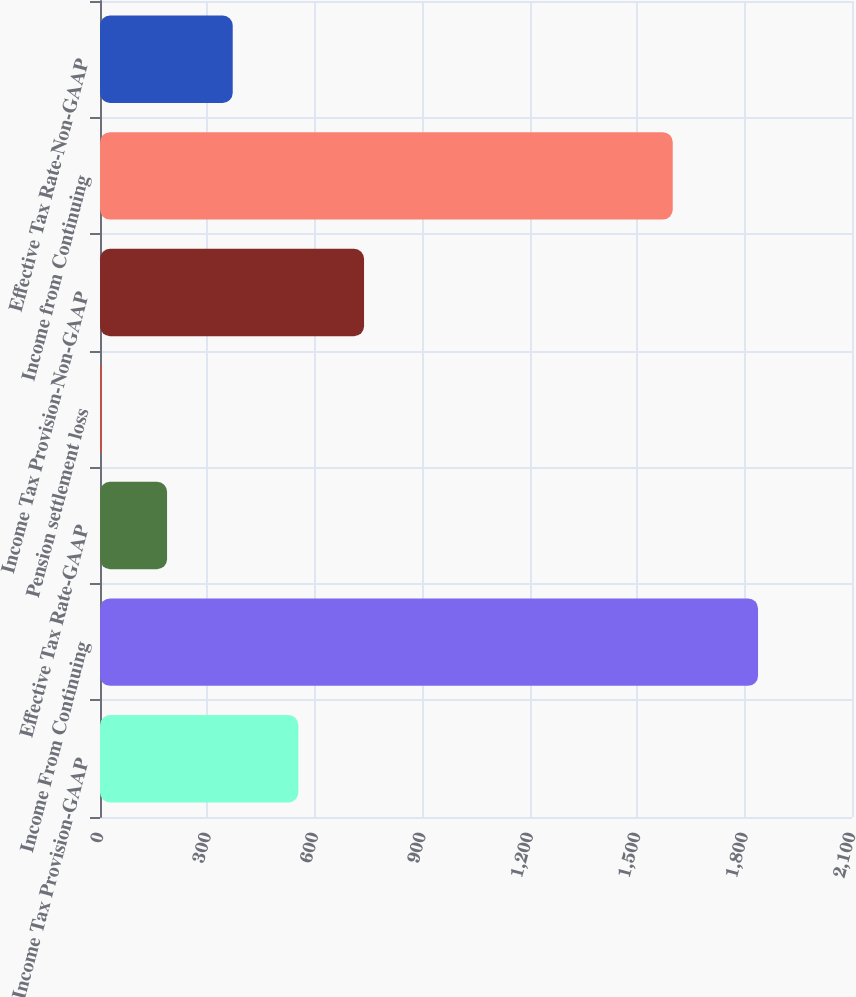Convert chart. <chart><loc_0><loc_0><loc_500><loc_500><bar_chart><fcel>Income Tax Provision-GAAP<fcel>Income From Continuing<fcel>Effective Tax Rate-GAAP<fcel>Pension settlement loss<fcel>Income Tax Provision-Non-GAAP<fcel>Income from Continuing<fcel>Effective Tax Rate-Non-GAAP<nl><fcel>554.01<fcel>1837.6<fcel>187.27<fcel>3.9<fcel>737.38<fcel>1599.47<fcel>370.64<nl></chart> 